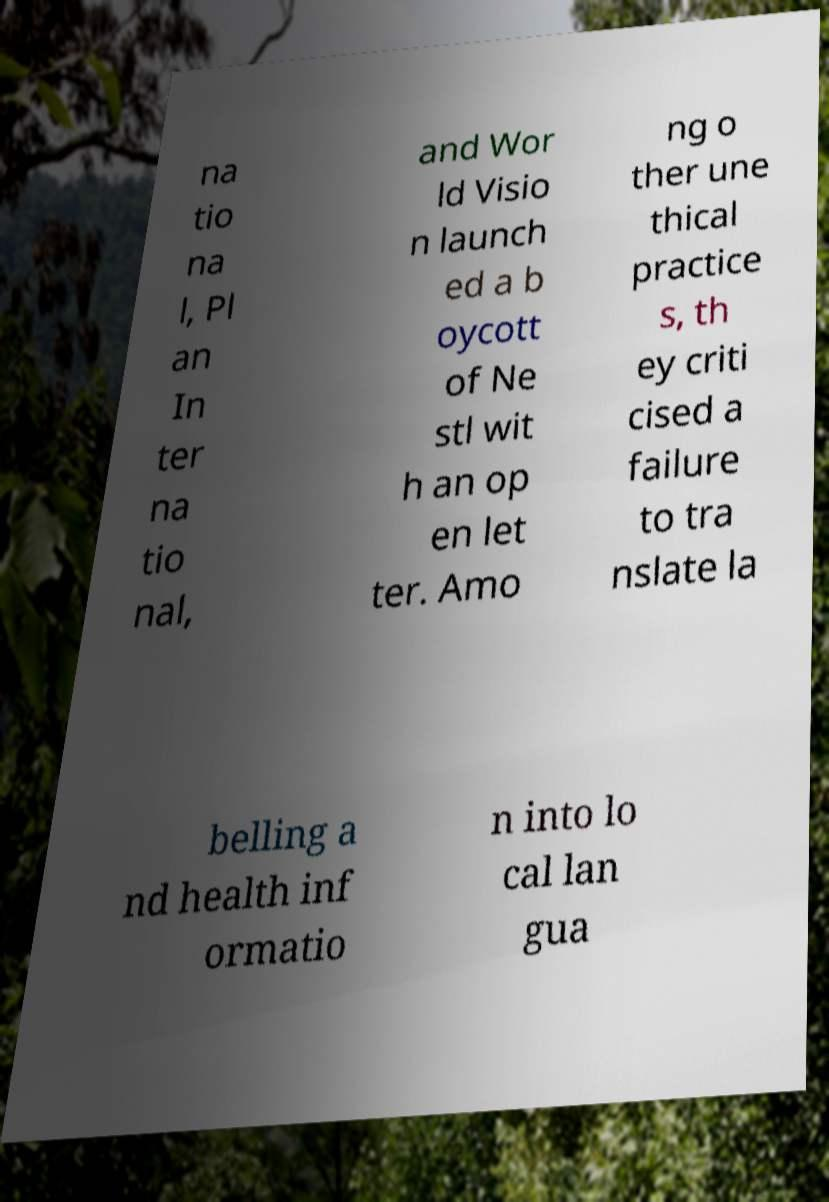Could you assist in decoding the text presented in this image and type it out clearly? na tio na l, Pl an In ter na tio nal, and Wor ld Visio n launch ed a b oycott of Ne stl wit h an op en let ter. Amo ng o ther une thical practice s, th ey criti cised a failure to tra nslate la belling a nd health inf ormatio n into lo cal lan gua 